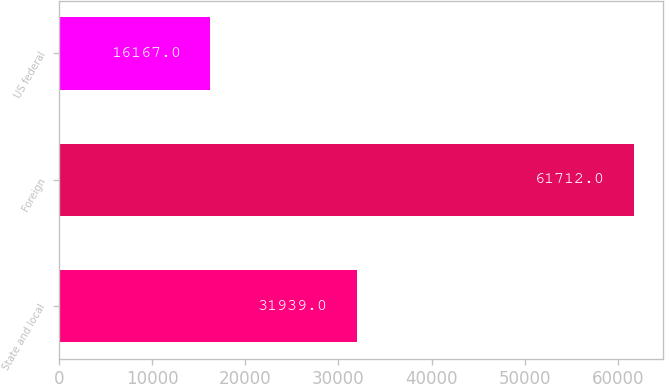Convert chart to OTSL. <chart><loc_0><loc_0><loc_500><loc_500><bar_chart><fcel>State and local<fcel>Foreign<fcel>US federal<nl><fcel>31939<fcel>61712<fcel>16167<nl></chart> 